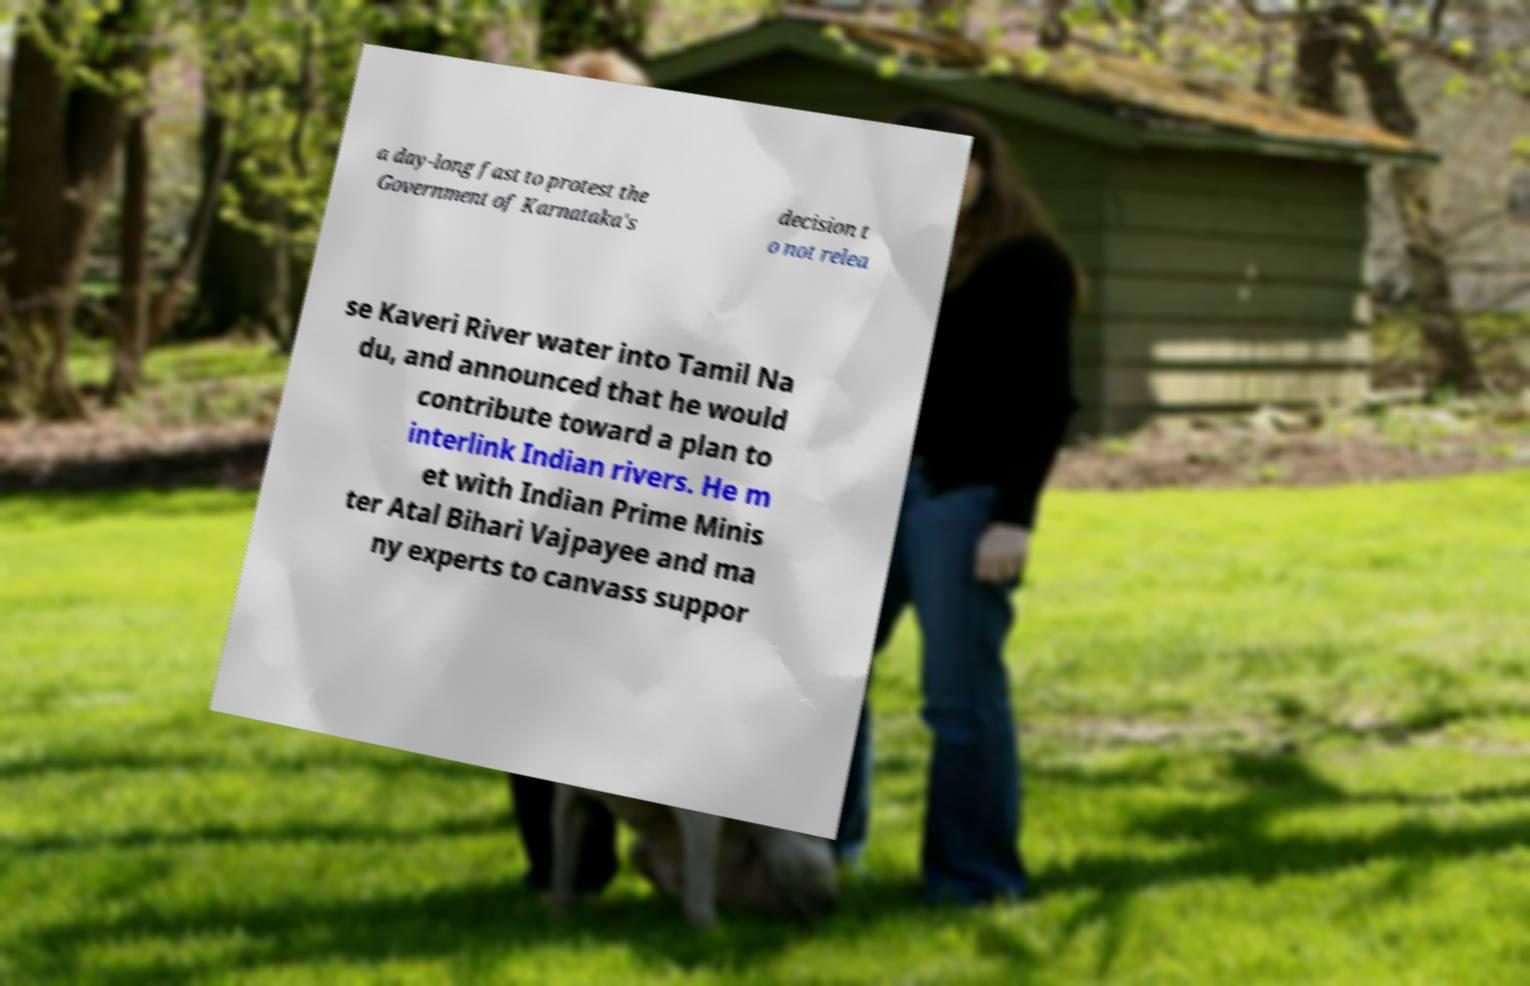What messages or text are displayed in this image? I need them in a readable, typed format. a day-long fast to protest the Government of Karnataka's decision t o not relea se Kaveri River water into Tamil Na du, and announced that he would contribute toward a plan to interlink Indian rivers. He m et with Indian Prime Minis ter Atal Bihari Vajpayee and ma ny experts to canvass suppor 